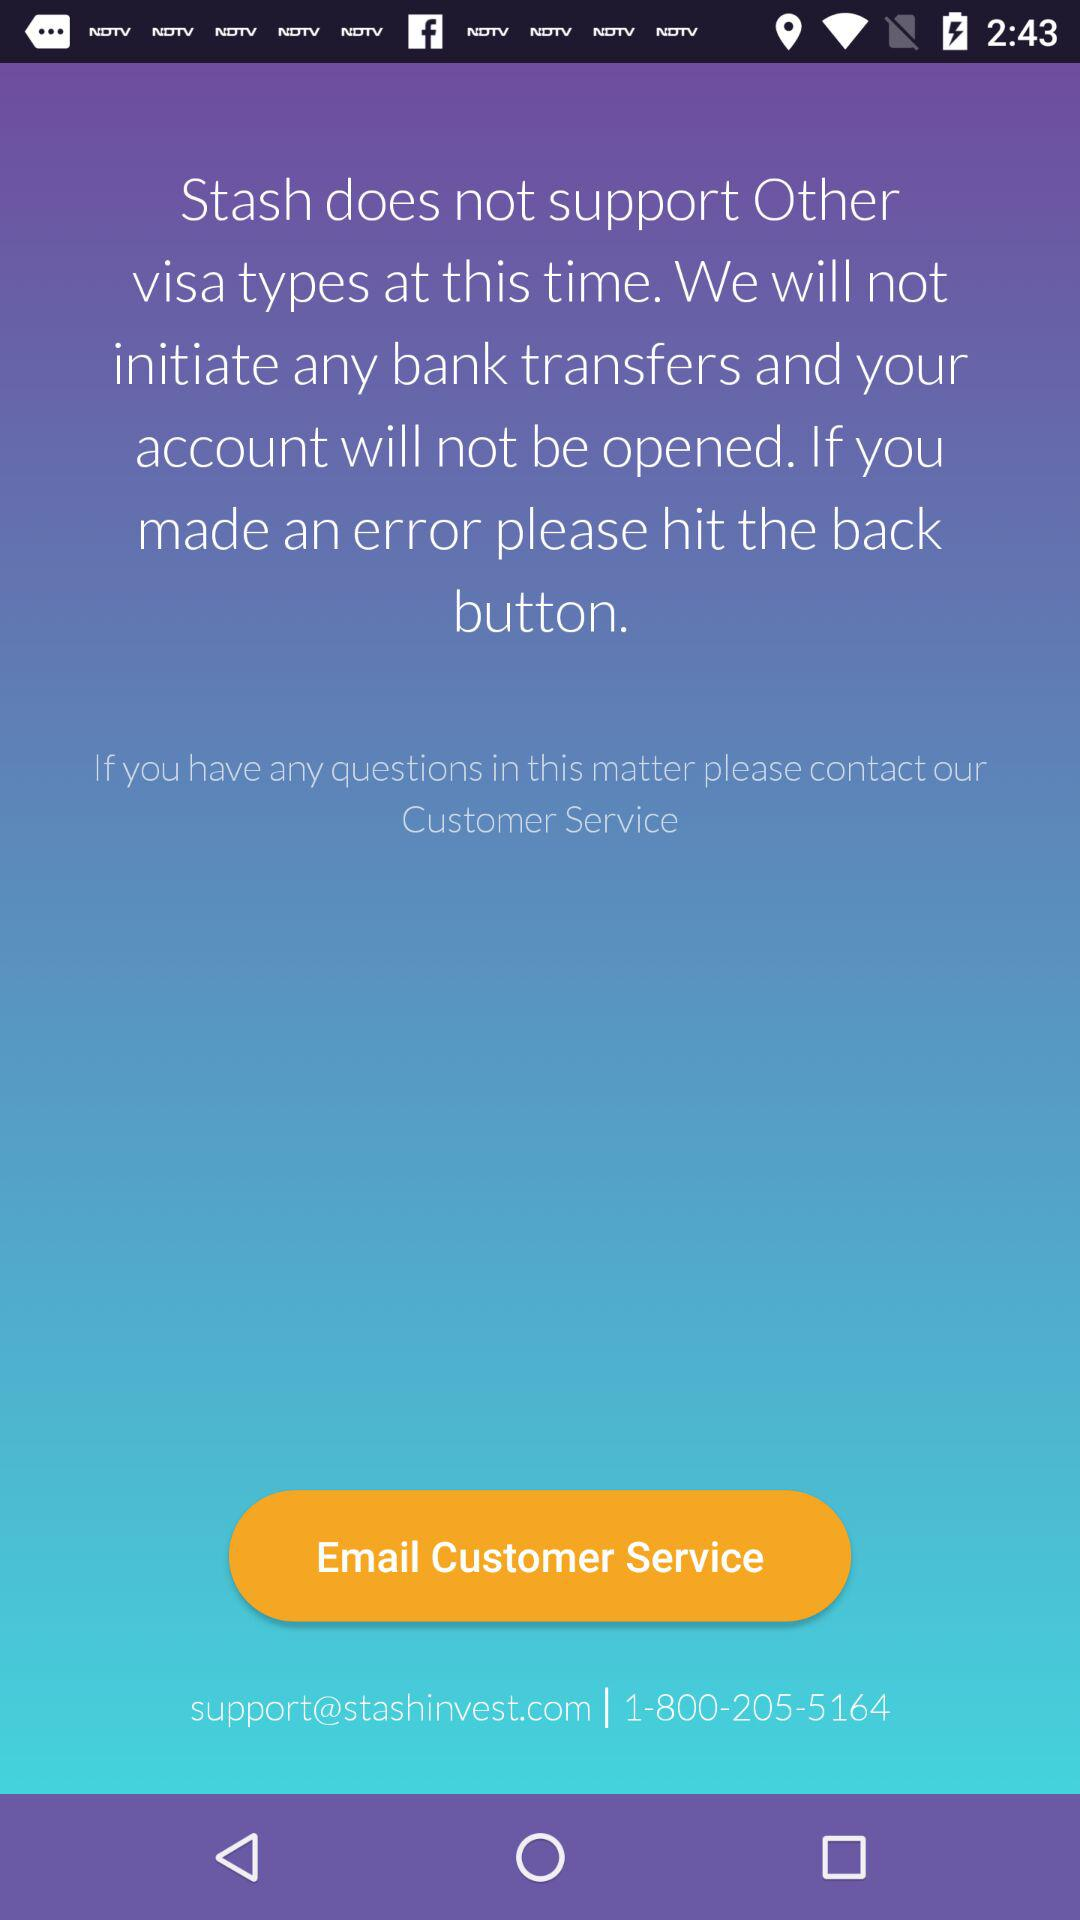What is the customer support email address? The customer support email address is support@stashinvest.com. 